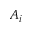<formula> <loc_0><loc_0><loc_500><loc_500>A _ { i }</formula> 